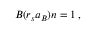<formula> <loc_0><loc_0><loc_500><loc_500>\begin{array} { r } { B ( r _ { s } a _ { B } ) n = 1 \, , } \end{array}</formula> 